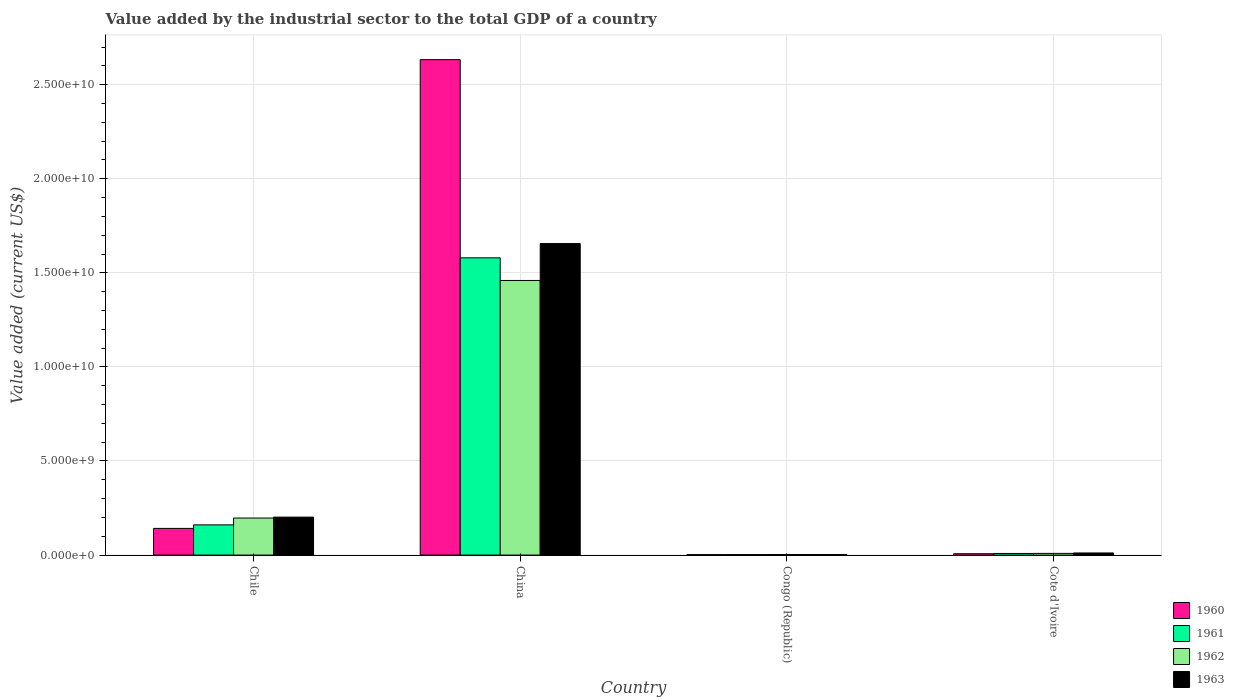How many different coloured bars are there?
Your response must be concise. 4. How many groups of bars are there?
Your answer should be very brief. 4. What is the label of the 1st group of bars from the left?
Ensure brevity in your answer.  Chile. What is the value added by the industrial sector to the total GDP in 1961 in Congo (Republic)?
Keep it short and to the point. 2.73e+07. Across all countries, what is the maximum value added by the industrial sector to the total GDP in 1961?
Give a very brief answer. 1.58e+1. Across all countries, what is the minimum value added by the industrial sector to the total GDP in 1960?
Make the answer very short. 2.24e+07. In which country was the value added by the industrial sector to the total GDP in 1961 maximum?
Give a very brief answer. China. In which country was the value added by the industrial sector to the total GDP in 1962 minimum?
Keep it short and to the point. Congo (Republic). What is the total value added by the industrial sector to the total GDP in 1962 in the graph?
Provide a short and direct response. 1.67e+1. What is the difference between the value added by the industrial sector to the total GDP in 1963 in Congo (Republic) and that in Cote d'Ivoire?
Give a very brief answer. -8.13e+07. What is the difference between the value added by the industrial sector to the total GDP in 1960 in Chile and the value added by the industrial sector to the total GDP in 1962 in Congo (Republic)?
Provide a short and direct response. 1.39e+09. What is the average value added by the industrial sector to the total GDP in 1962 per country?
Give a very brief answer. 4.17e+09. What is the difference between the value added by the industrial sector to the total GDP of/in 1960 and value added by the industrial sector to the total GDP of/in 1962 in Cote d'Ivoire?
Ensure brevity in your answer.  -1.85e+07. In how many countries, is the value added by the industrial sector to the total GDP in 1960 greater than 19000000000 US$?
Provide a succinct answer. 1. What is the ratio of the value added by the industrial sector to the total GDP in 1961 in China to that in Cote d'Ivoire?
Offer a terse response. 184.1. What is the difference between the highest and the second highest value added by the industrial sector to the total GDP in 1960?
Your answer should be compact. 2.63e+1. What is the difference between the highest and the lowest value added by the industrial sector to the total GDP in 1961?
Your response must be concise. 1.58e+1. In how many countries, is the value added by the industrial sector to the total GDP in 1960 greater than the average value added by the industrial sector to the total GDP in 1960 taken over all countries?
Your answer should be compact. 1. Is the sum of the value added by the industrial sector to the total GDP in 1961 in Chile and Congo (Republic) greater than the maximum value added by the industrial sector to the total GDP in 1962 across all countries?
Ensure brevity in your answer.  No. What does the 2nd bar from the left in Congo (Republic) represents?
Your answer should be compact. 1961. How many bars are there?
Make the answer very short. 16. Are all the bars in the graph horizontal?
Provide a short and direct response. No. Does the graph contain grids?
Provide a short and direct response. Yes. Where does the legend appear in the graph?
Make the answer very short. Bottom right. What is the title of the graph?
Your answer should be very brief. Value added by the industrial sector to the total GDP of a country. Does "1989" appear as one of the legend labels in the graph?
Your response must be concise. No. What is the label or title of the X-axis?
Your answer should be very brief. Country. What is the label or title of the Y-axis?
Ensure brevity in your answer.  Value added (current US$). What is the Value added (current US$) of 1960 in Chile?
Make the answer very short. 1.42e+09. What is the Value added (current US$) in 1961 in Chile?
Your answer should be compact. 1.61e+09. What is the Value added (current US$) of 1962 in Chile?
Keep it short and to the point. 1.97e+09. What is the Value added (current US$) in 1963 in Chile?
Make the answer very short. 2.02e+09. What is the Value added (current US$) in 1960 in China?
Your answer should be compact. 2.63e+1. What is the Value added (current US$) of 1961 in China?
Provide a succinct answer. 1.58e+1. What is the Value added (current US$) in 1962 in China?
Your answer should be very brief. 1.46e+1. What is the Value added (current US$) in 1963 in China?
Your answer should be very brief. 1.66e+1. What is the Value added (current US$) in 1960 in Congo (Republic)?
Keep it short and to the point. 2.24e+07. What is the Value added (current US$) of 1961 in Congo (Republic)?
Give a very brief answer. 2.73e+07. What is the Value added (current US$) of 1962 in Congo (Republic)?
Your response must be concise. 2.98e+07. What is the Value added (current US$) in 1963 in Congo (Republic)?
Your response must be concise. 3.06e+07. What is the Value added (current US$) in 1960 in Cote d'Ivoire?
Provide a succinct answer. 7.18e+07. What is the Value added (current US$) in 1961 in Cote d'Ivoire?
Give a very brief answer. 8.58e+07. What is the Value added (current US$) in 1962 in Cote d'Ivoire?
Provide a short and direct response. 9.02e+07. What is the Value added (current US$) of 1963 in Cote d'Ivoire?
Provide a short and direct response. 1.12e+08. Across all countries, what is the maximum Value added (current US$) in 1960?
Provide a short and direct response. 2.63e+1. Across all countries, what is the maximum Value added (current US$) in 1961?
Provide a succinct answer. 1.58e+1. Across all countries, what is the maximum Value added (current US$) of 1962?
Your response must be concise. 1.46e+1. Across all countries, what is the maximum Value added (current US$) of 1963?
Keep it short and to the point. 1.66e+1. Across all countries, what is the minimum Value added (current US$) in 1960?
Your answer should be very brief. 2.24e+07. Across all countries, what is the minimum Value added (current US$) in 1961?
Ensure brevity in your answer.  2.73e+07. Across all countries, what is the minimum Value added (current US$) of 1962?
Your answer should be compact. 2.98e+07. Across all countries, what is the minimum Value added (current US$) in 1963?
Ensure brevity in your answer.  3.06e+07. What is the total Value added (current US$) of 1960 in the graph?
Keep it short and to the point. 2.78e+1. What is the total Value added (current US$) in 1961 in the graph?
Ensure brevity in your answer.  1.75e+1. What is the total Value added (current US$) in 1962 in the graph?
Your answer should be very brief. 1.67e+1. What is the total Value added (current US$) of 1963 in the graph?
Offer a terse response. 1.87e+1. What is the difference between the Value added (current US$) of 1960 in Chile and that in China?
Provide a short and direct response. -2.49e+1. What is the difference between the Value added (current US$) of 1961 in Chile and that in China?
Your answer should be very brief. -1.42e+1. What is the difference between the Value added (current US$) of 1962 in Chile and that in China?
Offer a terse response. -1.26e+1. What is the difference between the Value added (current US$) in 1963 in Chile and that in China?
Provide a succinct answer. -1.45e+1. What is the difference between the Value added (current US$) of 1960 in Chile and that in Congo (Republic)?
Ensure brevity in your answer.  1.40e+09. What is the difference between the Value added (current US$) of 1961 in Chile and that in Congo (Republic)?
Give a very brief answer. 1.58e+09. What is the difference between the Value added (current US$) of 1962 in Chile and that in Congo (Republic)?
Your answer should be very brief. 1.94e+09. What is the difference between the Value added (current US$) of 1963 in Chile and that in Congo (Republic)?
Offer a very short reply. 1.99e+09. What is the difference between the Value added (current US$) in 1960 in Chile and that in Cote d'Ivoire?
Offer a very short reply. 1.35e+09. What is the difference between the Value added (current US$) of 1961 in Chile and that in Cote d'Ivoire?
Give a very brief answer. 1.52e+09. What is the difference between the Value added (current US$) of 1962 in Chile and that in Cote d'Ivoire?
Ensure brevity in your answer.  1.88e+09. What is the difference between the Value added (current US$) in 1963 in Chile and that in Cote d'Ivoire?
Provide a succinct answer. 1.91e+09. What is the difference between the Value added (current US$) of 1960 in China and that in Congo (Republic)?
Give a very brief answer. 2.63e+1. What is the difference between the Value added (current US$) of 1961 in China and that in Congo (Republic)?
Provide a succinct answer. 1.58e+1. What is the difference between the Value added (current US$) of 1962 in China and that in Congo (Republic)?
Offer a terse response. 1.46e+1. What is the difference between the Value added (current US$) of 1963 in China and that in Congo (Republic)?
Offer a very short reply. 1.65e+1. What is the difference between the Value added (current US$) of 1960 in China and that in Cote d'Ivoire?
Keep it short and to the point. 2.63e+1. What is the difference between the Value added (current US$) in 1961 in China and that in Cote d'Ivoire?
Make the answer very short. 1.57e+1. What is the difference between the Value added (current US$) in 1962 in China and that in Cote d'Ivoire?
Give a very brief answer. 1.45e+1. What is the difference between the Value added (current US$) in 1963 in China and that in Cote d'Ivoire?
Give a very brief answer. 1.64e+1. What is the difference between the Value added (current US$) in 1960 in Congo (Republic) and that in Cote d'Ivoire?
Your answer should be compact. -4.93e+07. What is the difference between the Value added (current US$) in 1961 in Congo (Republic) and that in Cote d'Ivoire?
Your response must be concise. -5.85e+07. What is the difference between the Value added (current US$) in 1962 in Congo (Republic) and that in Cote d'Ivoire?
Give a very brief answer. -6.04e+07. What is the difference between the Value added (current US$) of 1963 in Congo (Republic) and that in Cote d'Ivoire?
Give a very brief answer. -8.13e+07. What is the difference between the Value added (current US$) of 1960 in Chile and the Value added (current US$) of 1961 in China?
Keep it short and to the point. -1.44e+1. What is the difference between the Value added (current US$) of 1960 in Chile and the Value added (current US$) of 1962 in China?
Your answer should be very brief. -1.32e+1. What is the difference between the Value added (current US$) in 1960 in Chile and the Value added (current US$) in 1963 in China?
Provide a short and direct response. -1.51e+1. What is the difference between the Value added (current US$) of 1961 in Chile and the Value added (current US$) of 1962 in China?
Your answer should be very brief. -1.30e+1. What is the difference between the Value added (current US$) of 1961 in Chile and the Value added (current US$) of 1963 in China?
Ensure brevity in your answer.  -1.50e+1. What is the difference between the Value added (current US$) in 1962 in Chile and the Value added (current US$) in 1963 in China?
Ensure brevity in your answer.  -1.46e+1. What is the difference between the Value added (current US$) of 1960 in Chile and the Value added (current US$) of 1961 in Congo (Republic)?
Give a very brief answer. 1.39e+09. What is the difference between the Value added (current US$) of 1960 in Chile and the Value added (current US$) of 1962 in Congo (Republic)?
Provide a succinct answer. 1.39e+09. What is the difference between the Value added (current US$) in 1960 in Chile and the Value added (current US$) in 1963 in Congo (Republic)?
Offer a terse response. 1.39e+09. What is the difference between the Value added (current US$) of 1961 in Chile and the Value added (current US$) of 1962 in Congo (Republic)?
Give a very brief answer. 1.58e+09. What is the difference between the Value added (current US$) of 1961 in Chile and the Value added (current US$) of 1963 in Congo (Republic)?
Your answer should be compact. 1.57e+09. What is the difference between the Value added (current US$) in 1962 in Chile and the Value added (current US$) in 1963 in Congo (Republic)?
Offer a very short reply. 1.94e+09. What is the difference between the Value added (current US$) in 1960 in Chile and the Value added (current US$) in 1961 in Cote d'Ivoire?
Keep it short and to the point. 1.33e+09. What is the difference between the Value added (current US$) in 1960 in Chile and the Value added (current US$) in 1962 in Cote d'Ivoire?
Keep it short and to the point. 1.33e+09. What is the difference between the Value added (current US$) in 1960 in Chile and the Value added (current US$) in 1963 in Cote d'Ivoire?
Your response must be concise. 1.31e+09. What is the difference between the Value added (current US$) of 1961 in Chile and the Value added (current US$) of 1962 in Cote d'Ivoire?
Your answer should be compact. 1.52e+09. What is the difference between the Value added (current US$) in 1961 in Chile and the Value added (current US$) in 1963 in Cote d'Ivoire?
Ensure brevity in your answer.  1.49e+09. What is the difference between the Value added (current US$) of 1962 in Chile and the Value added (current US$) of 1963 in Cote d'Ivoire?
Your answer should be very brief. 1.86e+09. What is the difference between the Value added (current US$) of 1960 in China and the Value added (current US$) of 1961 in Congo (Republic)?
Provide a succinct answer. 2.63e+1. What is the difference between the Value added (current US$) in 1960 in China and the Value added (current US$) in 1962 in Congo (Republic)?
Keep it short and to the point. 2.63e+1. What is the difference between the Value added (current US$) of 1960 in China and the Value added (current US$) of 1963 in Congo (Republic)?
Ensure brevity in your answer.  2.63e+1. What is the difference between the Value added (current US$) of 1961 in China and the Value added (current US$) of 1962 in Congo (Republic)?
Offer a very short reply. 1.58e+1. What is the difference between the Value added (current US$) in 1961 in China and the Value added (current US$) in 1963 in Congo (Republic)?
Your response must be concise. 1.58e+1. What is the difference between the Value added (current US$) in 1962 in China and the Value added (current US$) in 1963 in Congo (Republic)?
Offer a very short reply. 1.46e+1. What is the difference between the Value added (current US$) of 1960 in China and the Value added (current US$) of 1961 in Cote d'Ivoire?
Ensure brevity in your answer.  2.62e+1. What is the difference between the Value added (current US$) of 1960 in China and the Value added (current US$) of 1962 in Cote d'Ivoire?
Keep it short and to the point. 2.62e+1. What is the difference between the Value added (current US$) of 1960 in China and the Value added (current US$) of 1963 in Cote d'Ivoire?
Make the answer very short. 2.62e+1. What is the difference between the Value added (current US$) of 1961 in China and the Value added (current US$) of 1962 in Cote d'Ivoire?
Offer a terse response. 1.57e+1. What is the difference between the Value added (current US$) of 1961 in China and the Value added (current US$) of 1963 in Cote d'Ivoire?
Provide a succinct answer. 1.57e+1. What is the difference between the Value added (current US$) of 1962 in China and the Value added (current US$) of 1963 in Cote d'Ivoire?
Your answer should be compact. 1.45e+1. What is the difference between the Value added (current US$) of 1960 in Congo (Republic) and the Value added (current US$) of 1961 in Cote d'Ivoire?
Offer a very short reply. -6.34e+07. What is the difference between the Value added (current US$) in 1960 in Congo (Republic) and the Value added (current US$) in 1962 in Cote d'Ivoire?
Make the answer very short. -6.78e+07. What is the difference between the Value added (current US$) in 1960 in Congo (Republic) and the Value added (current US$) in 1963 in Cote d'Ivoire?
Keep it short and to the point. -8.94e+07. What is the difference between the Value added (current US$) in 1961 in Congo (Republic) and the Value added (current US$) in 1962 in Cote d'Ivoire?
Your answer should be compact. -6.29e+07. What is the difference between the Value added (current US$) of 1961 in Congo (Republic) and the Value added (current US$) of 1963 in Cote d'Ivoire?
Provide a short and direct response. -8.46e+07. What is the difference between the Value added (current US$) of 1962 in Congo (Republic) and the Value added (current US$) of 1963 in Cote d'Ivoire?
Keep it short and to the point. -8.21e+07. What is the average Value added (current US$) of 1960 per country?
Give a very brief answer. 6.96e+09. What is the average Value added (current US$) of 1961 per country?
Provide a succinct answer. 4.38e+09. What is the average Value added (current US$) in 1962 per country?
Ensure brevity in your answer.  4.17e+09. What is the average Value added (current US$) of 1963 per country?
Offer a very short reply. 4.68e+09. What is the difference between the Value added (current US$) in 1960 and Value added (current US$) in 1961 in Chile?
Your answer should be very brief. -1.88e+08. What is the difference between the Value added (current US$) of 1960 and Value added (current US$) of 1962 in Chile?
Keep it short and to the point. -5.50e+08. What is the difference between the Value added (current US$) in 1960 and Value added (current US$) in 1963 in Chile?
Provide a short and direct response. -5.99e+08. What is the difference between the Value added (current US$) in 1961 and Value added (current US$) in 1962 in Chile?
Give a very brief answer. -3.63e+08. What is the difference between the Value added (current US$) in 1961 and Value added (current US$) in 1963 in Chile?
Your response must be concise. -4.12e+08. What is the difference between the Value added (current US$) of 1962 and Value added (current US$) of 1963 in Chile?
Ensure brevity in your answer.  -4.92e+07. What is the difference between the Value added (current US$) of 1960 and Value added (current US$) of 1961 in China?
Your answer should be compact. 1.05e+1. What is the difference between the Value added (current US$) in 1960 and Value added (current US$) in 1962 in China?
Provide a short and direct response. 1.17e+1. What is the difference between the Value added (current US$) of 1960 and Value added (current US$) of 1963 in China?
Your answer should be compact. 9.77e+09. What is the difference between the Value added (current US$) of 1961 and Value added (current US$) of 1962 in China?
Ensure brevity in your answer.  1.20e+09. What is the difference between the Value added (current US$) in 1961 and Value added (current US$) in 1963 in China?
Offer a very short reply. -7.60e+08. What is the difference between the Value added (current US$) in 1962 and Value added (current US$) in 1963 in China?
Your response must be concise. -1.96e+09. What is the difference between the Value added (current US$) of 1960 and Value added (current US$) of 1961 in Congo (Republic)?
Your answer should be compact. -4.89e+06. What is the difference between the Value added (current US$) of 1960 and Value added (current US$) of 1962 in Congo (Republic)?
Your answer should be very brief. -7.36e+06. What is the difference between the Value added (current US$) in 1960 and Value added (current US$) in 1963 in Congo (Republic)?
Your answer should be very brief. -8.18e+06. What is the difference between the Value added (current US$) of 1961 and Value added (current US$) of 1962 in Congo (Republic)?
Your answer should be compact. -2.48e+06. What is the difference between the Value added (current US$) in 1961 and Value added (current US$) in 1963 in Congo (Republic)?
Provide a succinct answer. -3.29e+06. What is the difference between the Value added (current US$) of 1962 and Value added (current US$) of 1963 in Congo (Republic)?
Make the answer very short. -8.16e+05. What is the difference between the Value added (current US$) in 1960 and Value added (current US$) in 1961 in Cote d'Ivoire?
Give a very brief answer. -1.40e+07. What is the difference between the Value added (current US$) of 1960 and Value added (current US$) of 1962 in Cote d'Ivoire?
Provide a succinct answer. -1.85e+07. What is the difference between the Value added (current US$) in 1960 and Value added (current US$) in 1963 in Cote d'Ivoire?
Ensure brevity in your answer.  -4.01e+07. What is the difference between the Value added (current US$) of 1961 and Value added (current US$) of 1962 in Cote d'Ivoire?
Give a very brief answer. -4.42e+06. What is the difference between the Value added (current US$) of 1961 and Value added (current US$) of 1963 in Cote d'Ivoire?
Offer a very short reply. -2.61e+07. What is the difference between the Value added (current US$) of 1962 and Value added (current US$) of 1963 in Cote d'Ivoire?
Provide a short and direct response. -2.17e+07. What is the ratio of the Value added (current US$) of 1960 in Chile to that in China?
Offer a very short reply. 0.05. What is the ratio of the Value added (current US$) of 1961 in Chile to that in China?
Give a very brief answer. 0.1. What is the ratio of the Value added (current US$) of 1962 in Chile to that in China?
Your answer should be compact. 0.13. What is the ratio of the Value added (current US$) in 1963 in Chile to that in China?
Provide a short and direct response. 0.12. What is the ratio of the Value added (current US$) in 1960 in Chile to that in Congo (Republic)?
Offer a very short reply. 63.21. What is the ratio of the Value added (current US$) of 1961 in Chile to that in Congo (Republic)?
Provide a succinct answer. 58.77. What is the ratio of the Value added (current US$) in 1962 in Chile to that in Congo (Republic)?
Provide a succinct answer. 66.06. What is the ratio of the Value added (current US$) in 1963 in Chile to that in Congo (Republic)?
Ensure brevity in your answer.  65.9. What is the ratio of the Value added (current US$) of 1960 in Chile to that in Cote d'Ivoire?
Ensure brevity in your answer.  19.76. What is the ratio of the Value added (current US$) of 1961 in Chile to that in Cote d'Ivoire?
Your answer should be very brief. 18.71. What is the ratio of the Value added (current US$) of 1962 in Chile to that in Cote d'Ivoire?
Your response must be concise. 21.81. What is the ratio of the Value added (current US$) in 1963 in Chile to that in Cote d'Ivoire?
Make the answer very short. 18.03. What is the ratio of the Value added (current US$) of 1960 in China to that in Congo (Republic)?
Ensure brevity in your answer.  1173.83. What is the ratio of the Value added (current US$) in 1961 in China to that in Congo (Republic)?
Ensure brevity in your answer.  578.28. What is the ratio of the Value added (current US$) in 1962 in China to that in Congo (Republic)?
Offer a terse response. 489.86. What is the ratio of the Value added (current US$) in 1963 in China to that in Congo (Republic)?
Give a very brief answer. 540.9. What is the ratio of the Value added (current US$) in 1960 in China to that in Cote d'Ivoire?
Offer a terse response. 366.9. What is the ratio of the Value added (current US$) in 1961 in China to that in Cote d'Ivoire?
Give a very brief answer. 184.1. What is the ratio of the Value added (current US$) in 1962 in China to that in Cote d'Ivoire?
Keep it short and to the point. 161.77. What is the ratio of the Value added (current US$) in 1963 in China to that in Cote d'Ivoire?
Your response must be concise. 147.99. What is the ratio of the Value added (current US$) of 1960 in Congo (Republic) to that in Cote d'Ivoire?
Your response must be concise. 0.31. What is the ratio of the Value added (current US$) of 1961 in Congo (Republic) to that in Cote d'Ivoire?
Provide a short and direct response. 0.32. What is the ratio of the Value added (current US$) of 1962 in Congo (Republic) to that in Cote d'Ivoire?
Your answer should be compact. 0.33. What is the ratio of the Value added (current US$) in 1963 in Congo (Republic) to that in Cote d'Ivoire?
Provide a succinct answer. 0.27. What is the difference between the highest and the second highest Value added (current US$) in 1960?
Provide a succinct answer. 2.49e+1. What is the difference between the highest and the second highest Value added (current US$) in 1961?
Your answer should be very brief. 1.42e+1. What is the difference between the highest and the second highest Value added (current US$) in 1962?
Offer a very short reply. 1.26e+1. What is the difference between the highest and the second highest Value added (current US$) in 1963?
Keep it short and to the point. 1.45e+1. What is the difference between the highest and the lowest Value added (current US$) of 1960?
Ensure brevity in your answer.  2.63e+1. What is the difference between the highest and the lowest Value added (current US$) of 1961?
Offer a terse response. 1.58e+1. What is the difference between the highest and the lowest Value added (current US$) of 1962?
Offer a terse response. 1.46e+1. What is the difference between the highest and the lowest Value added (current US$) of 1963?
Offer a terse response. 1.65e+1. 